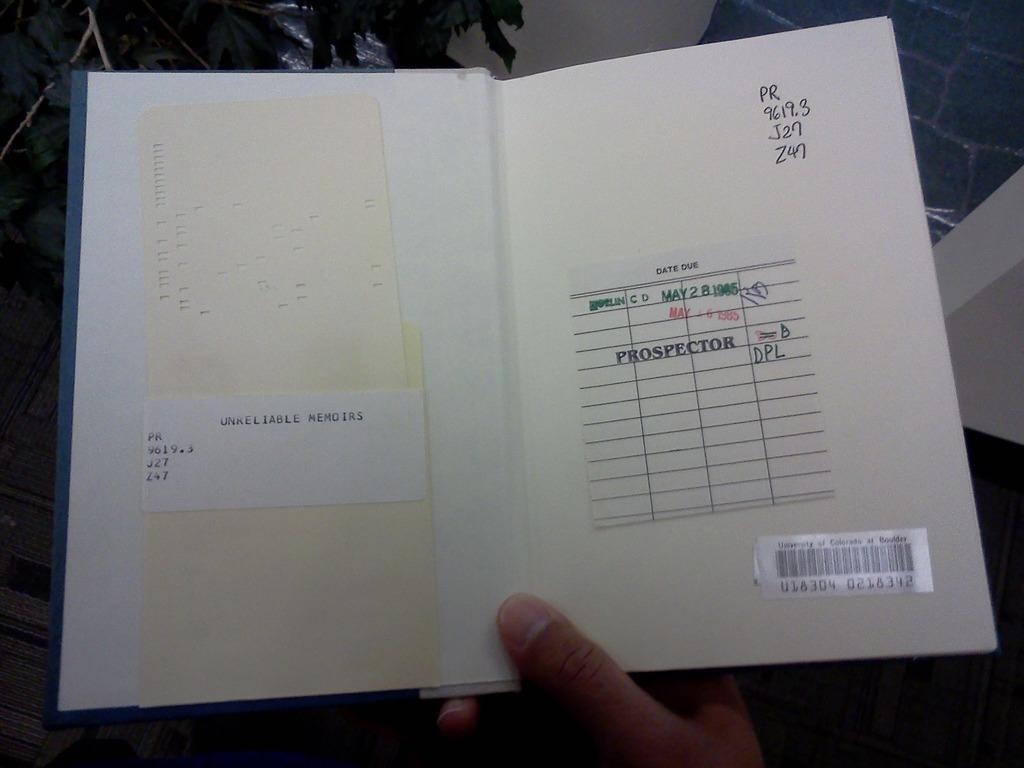<image>
Offer a succinct explanation of the picture presented. A library book is from the University of Colorado at Boulder. 